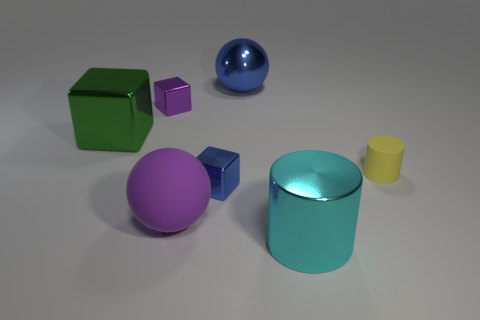Add 3 purple rubber balls. How many objects exist? 10 Subtract all spheres. How many objects are left? 5 Add 4 purple metallic objects. How many purple metallic objects exist? 5 Subtract 0 blue cylinders. How many objects are left? 7 Subtract all red metal spheres. Subtract all big things. How many objects are left? 3 Add 2 purple rubber balls. How many purple rubber balls are left? 3 